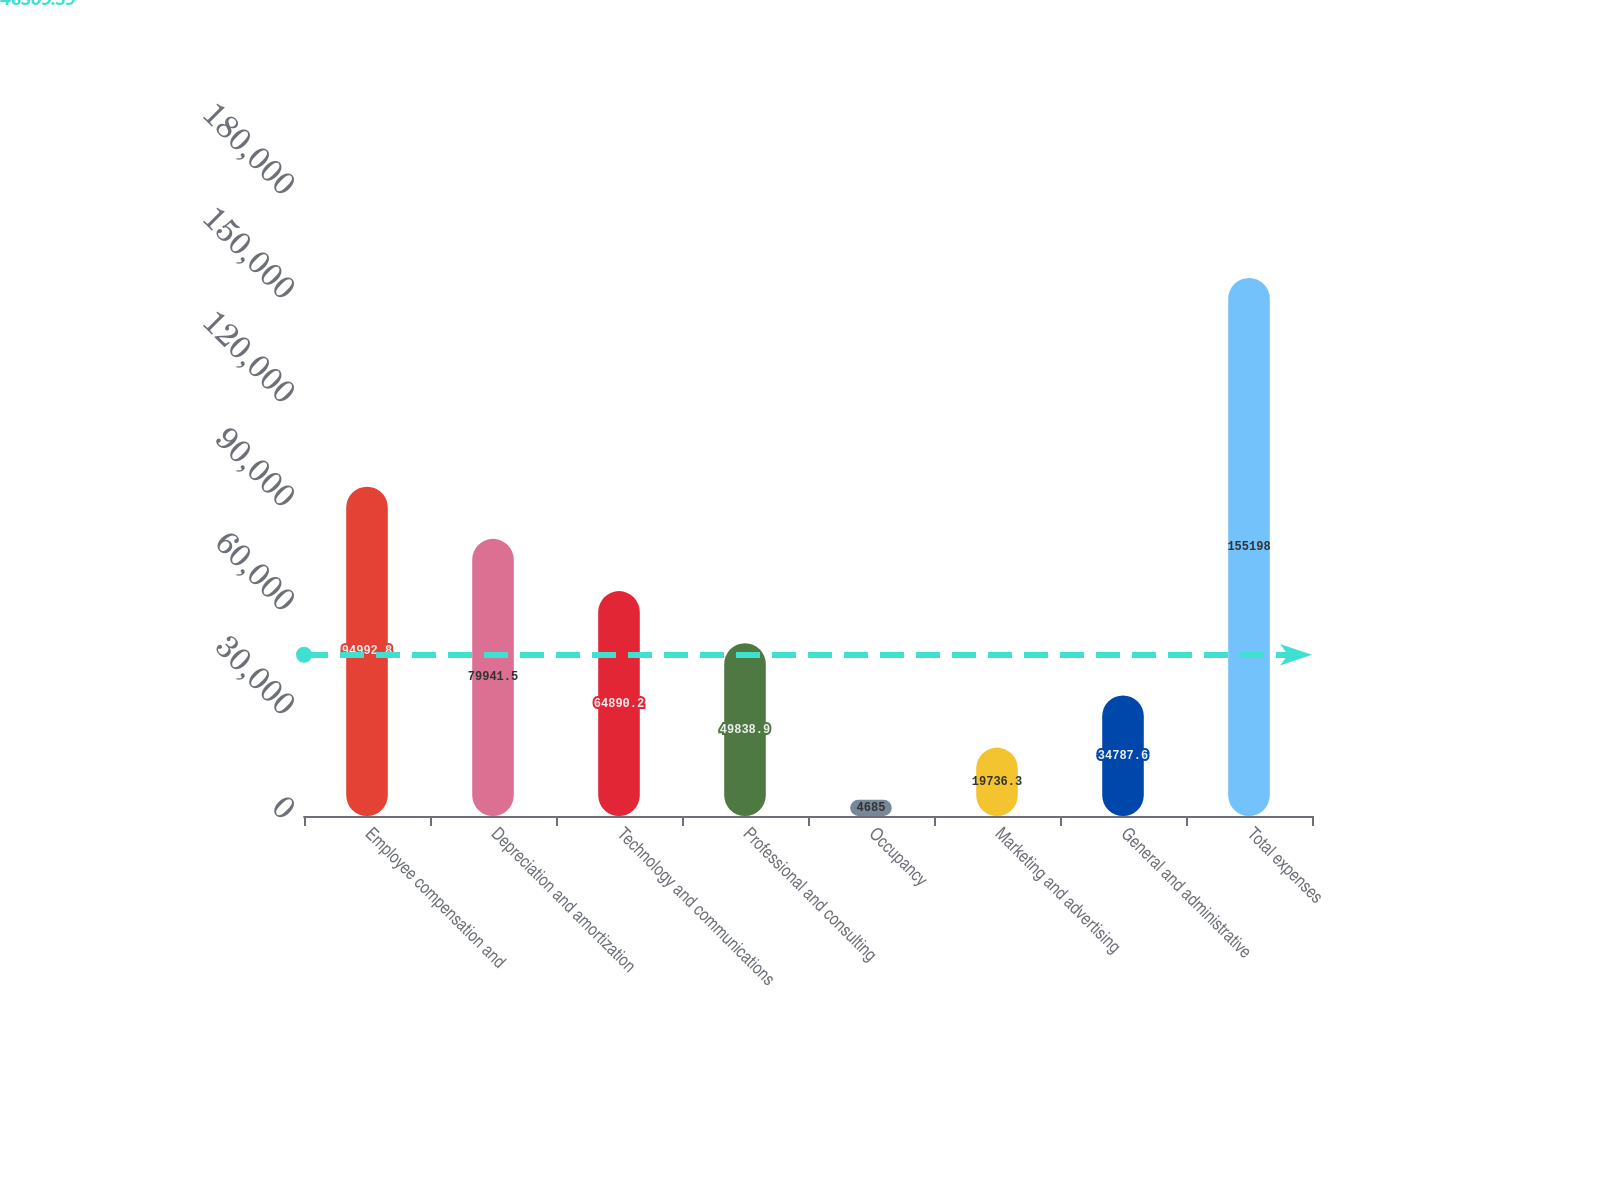Convert chart to OTSL. <chart><loc_0><loc_0><loc_500><loc_500><bar_chart><fcel>Employee compensation and<fcel>Depreciation and amortization<fcel>Technology and communications<fcel>Professional and consulting<fcel>Occupancy<fcel>Marketing and advertising<fcel>General and administrative<fcel>Total expenses<nl><fcel>94992.8<fcel>79941.5<fcel>64890.2<fcel>49838.9<fcel>4685<fcel>19736.3<fcel>34787.6<fcel>155198<nl></chart> 